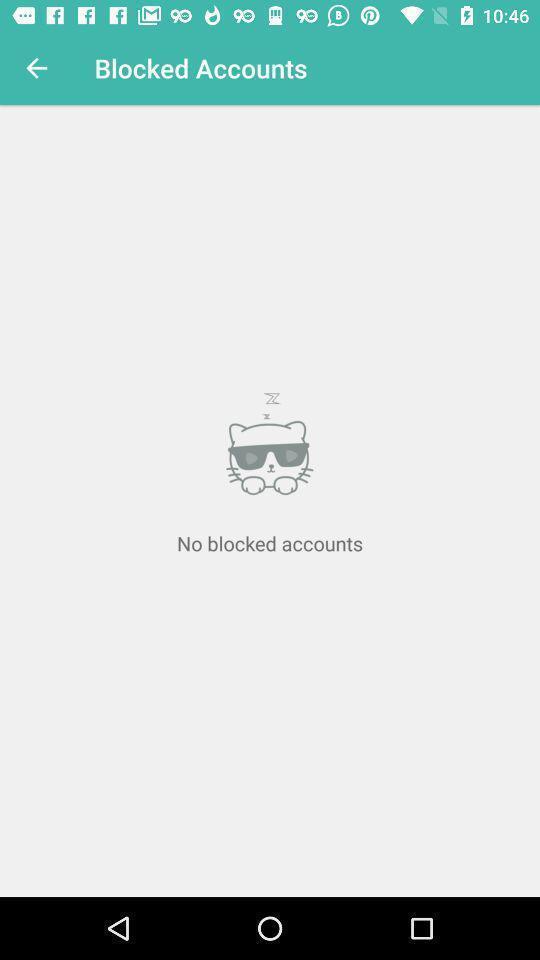Describe the visual elements of this screenshot. Screen showing no blocked accounts. 